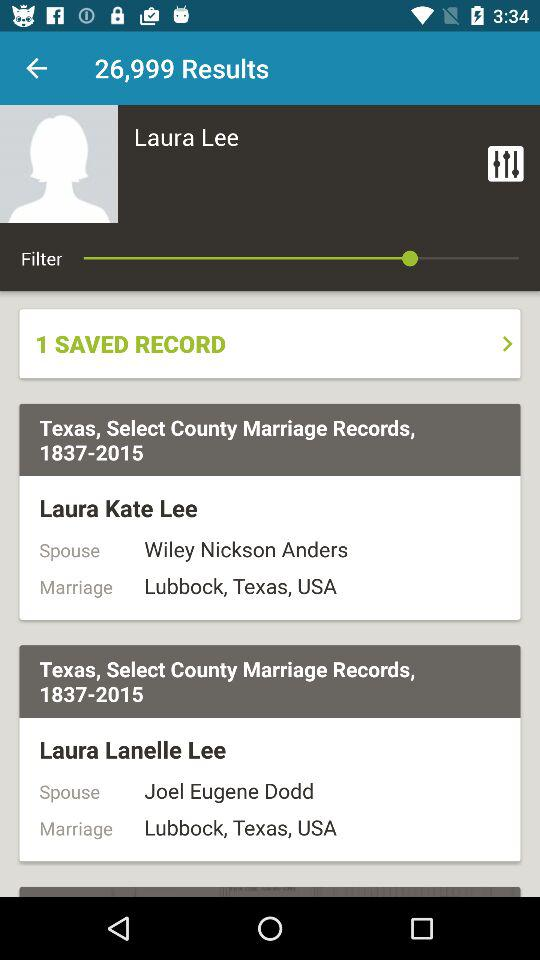How many results are showing? There are 26,999 results. 